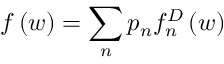<formula> <loc_0><loc_0><loc_500><loc_500>f \left ( w \right ) = \sum _ { n } p _ { n } f _ { n } ^ { D } \left ( w \right )</formula> 